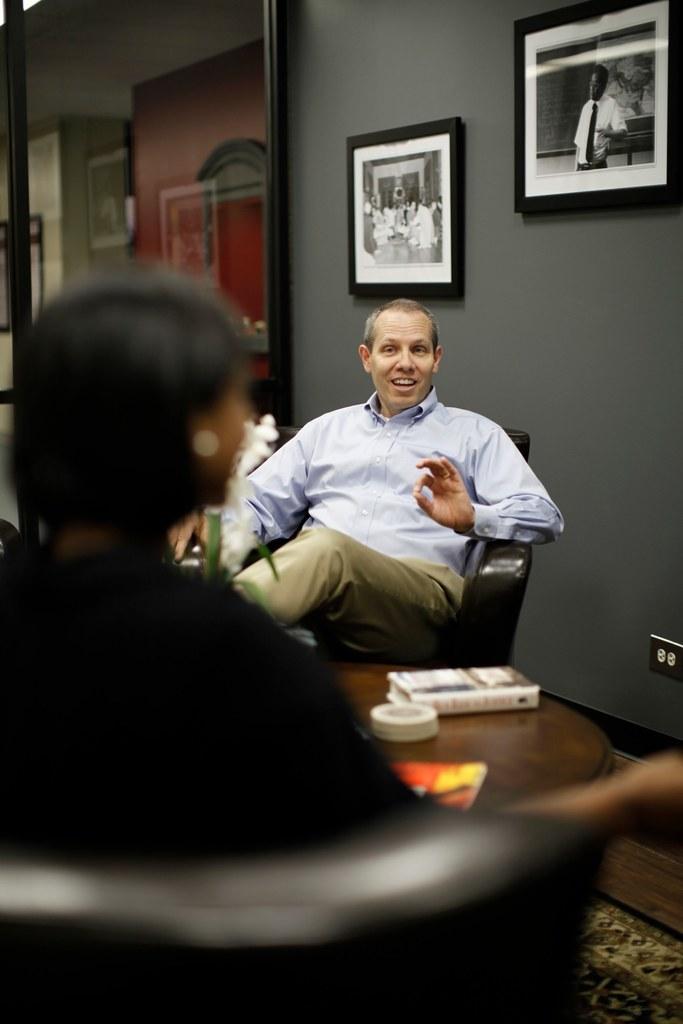Can you describe this image briefly? In the picture we can see a man sitting on a chair in the opposite there is a person sitting on a chair, between them there is a table, on the table we can see ash tray and tray placed on it, in the background we can see a wall and photo frames hand to it. 